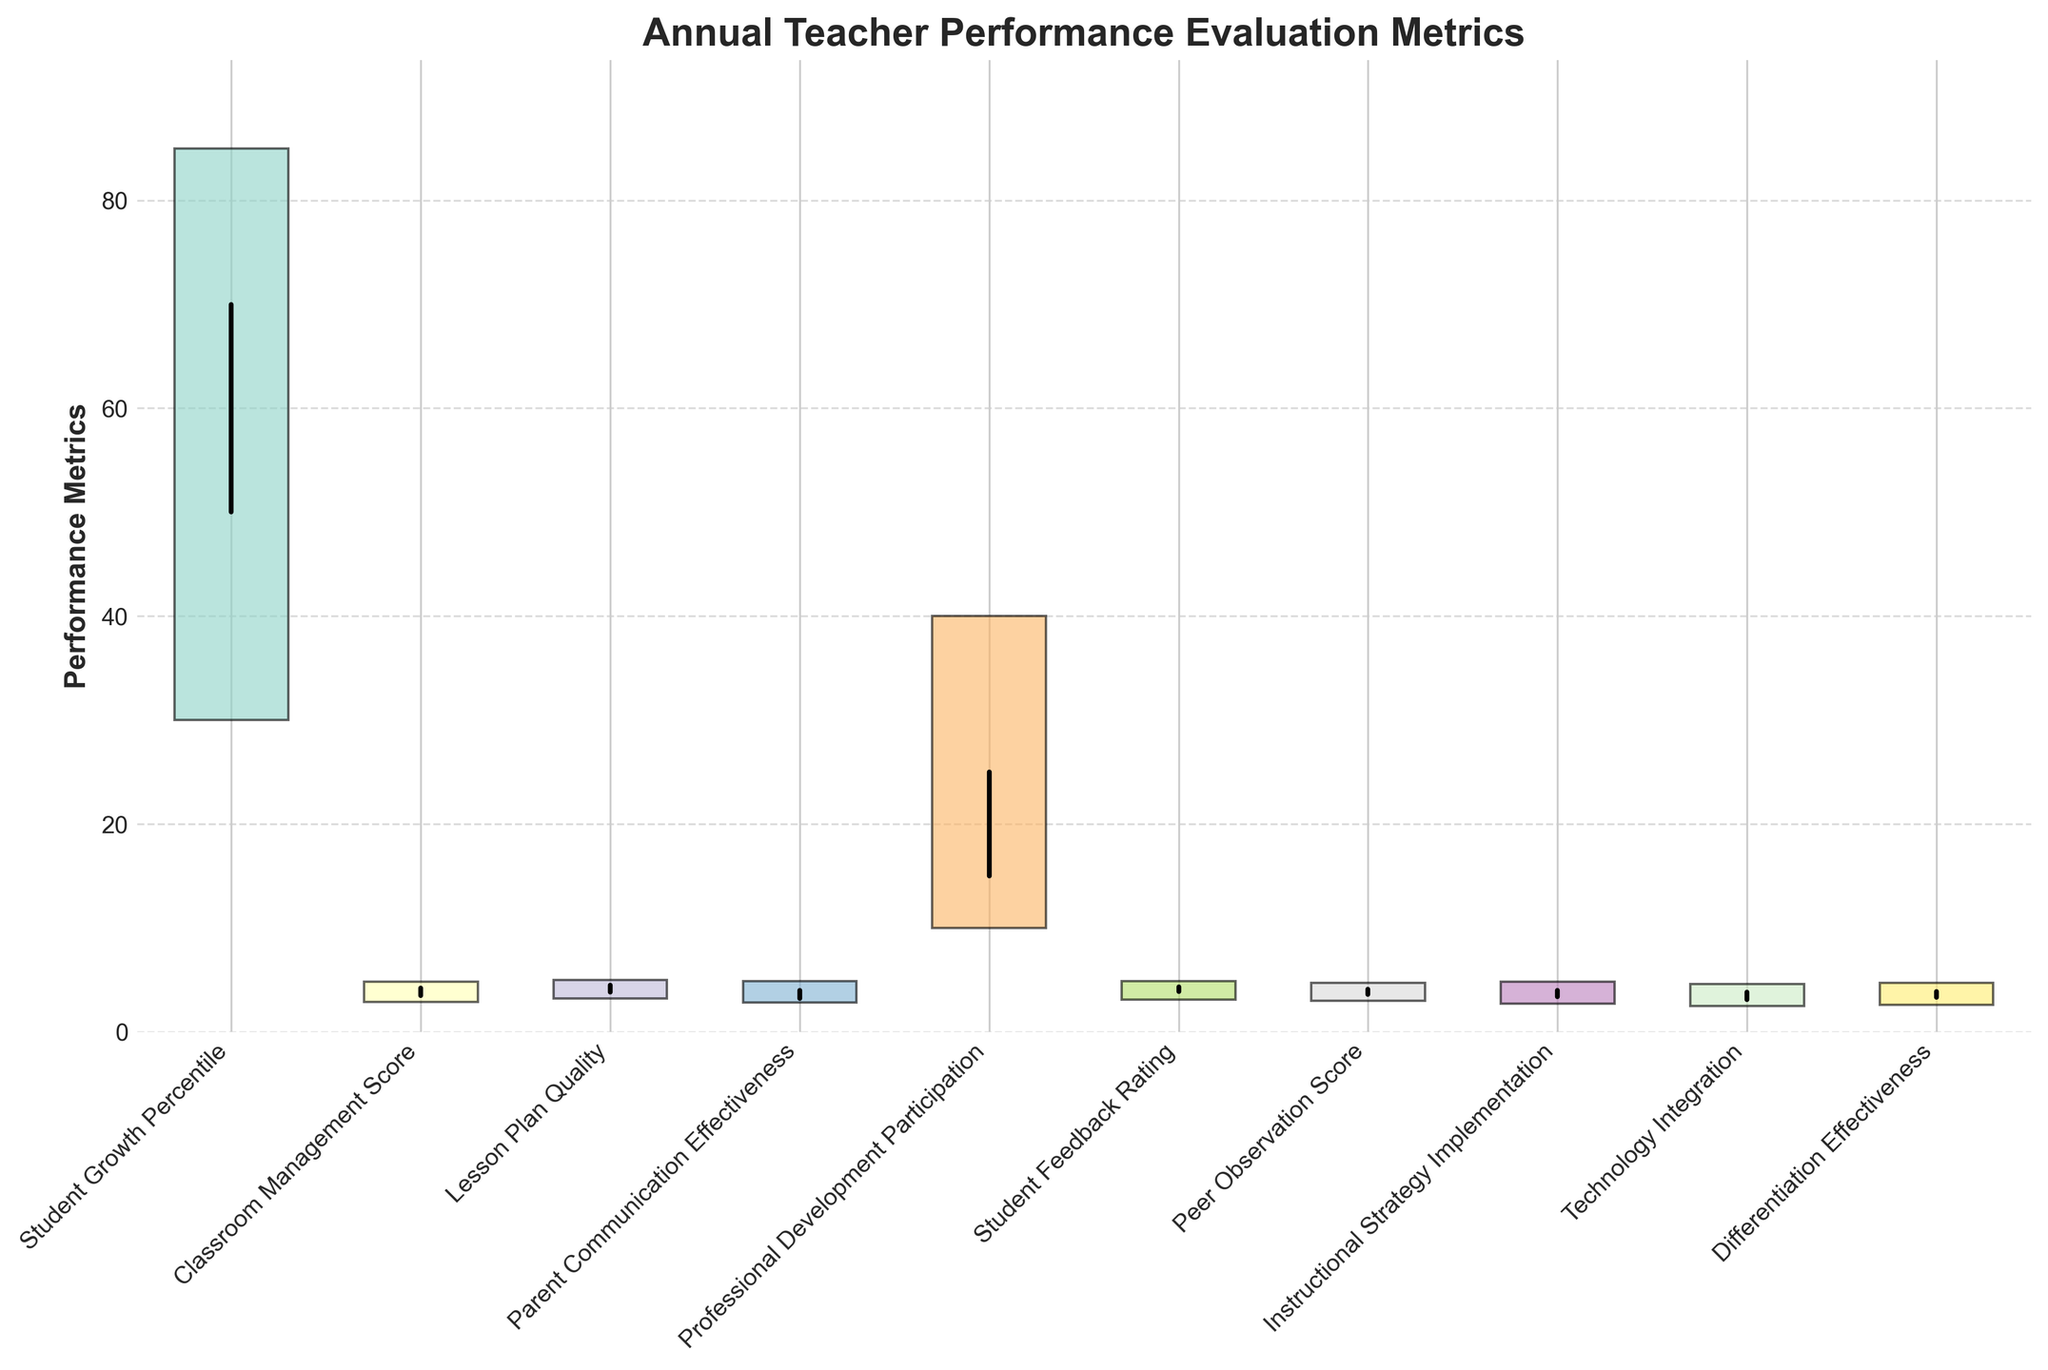What's the highest value reached in Lesson Plan Quality? The highest value is indicated by the top of the rectangle for Lesson Plan Quality.
Answer: 5.0 Which performance metric has the largest range between the high and low values? To find the largest range, subtract the low value from the high value for each metric and compare them. The range for each is as follows: (Student Growth Percentile: 85-30=55, Classroom Management Score: 4.8-2.9=1.9, etc.). The largest difference is 55 for Student Growth Percentile.
Answer: Student Growth Percentile What is the average of the closing values for Classroom Management Score and Parent Communication Effectiveness? Add the closing values for both metrics and divide by 2: (4.2 + 4.0) / 2 = 4.1
Answer: 4.1 Which metric showed the highest improvement from its open value to its close value? Improvement is found by subtracting the open value from the close value. The improvements are: (Student Growth Percentile: 70-50=20, etc.). The highest improvement is 20 for Student Growth Percentile.
Answer: Student Growth Percentile What is the highest close value among all metrics? The highest close value is identified by comparing all the close values: 70 (Student Growth Percentile), 4.2 (Classroom Management Score), etc. The highest is 70.
Answer: 70 Which metric had the smallest difference between its open and close values? By calculating the differences: (Student Growth Percentile: 70-50=20, etc.), find the smallest difference. In this case, Professional Development Participation has the smallest difference of 10.
Answer: Professional Development Participation What is the median close value for the Teacher Performance Metrics? Sort the close values, find the middle value: [4.0, 4.0, 4.1, 4.2, 4.3, 4.5, 4.5, 4.5, 4.5, 70]. Median is the average of the 5th and 6th values: (4.25 + 4.5) / 2 = 4.35.
Answer: 4.35 Which metric had the lowest high value? To identify the lowest high value, compare the high values of each metric: 85, 4.8, 5.0, 4.9, 40, 4.9, 4.7, 4.8, 4.6, 4.7. The lowest high value is 4.6 for Technology Integration.
Answer: Technology Integration 